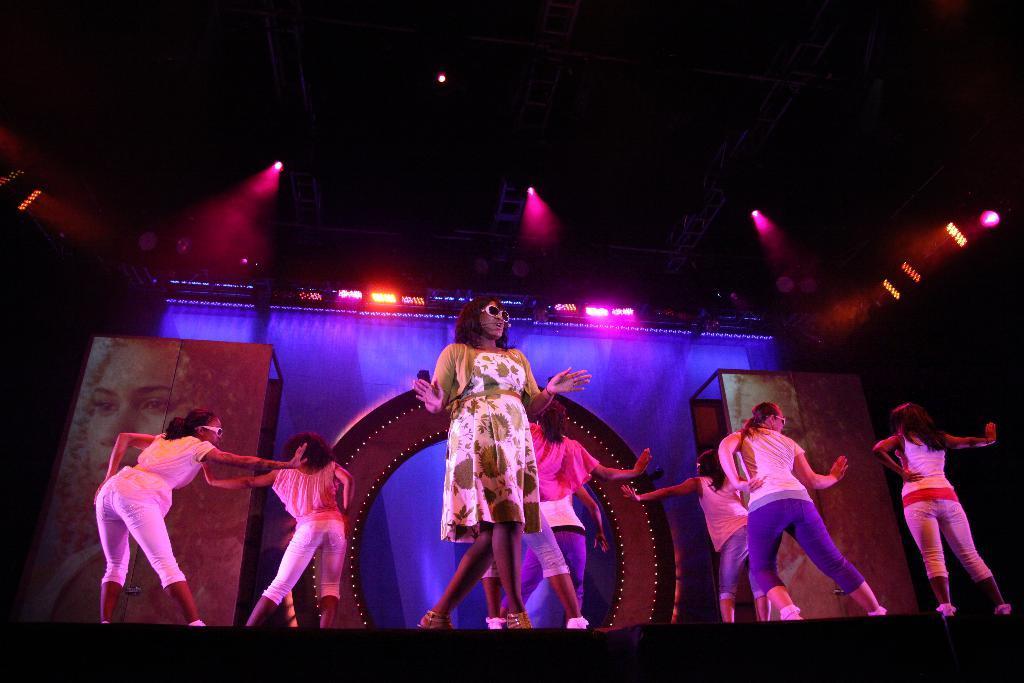Describe this image in one or two sentences. This image is clicked on stage, there is a girl in the front wearing a white and yellow color frock singing and walking, behind her there are many girls dancing and there are colorful lights on the ceiling and on the wall there is banner and cloth. 